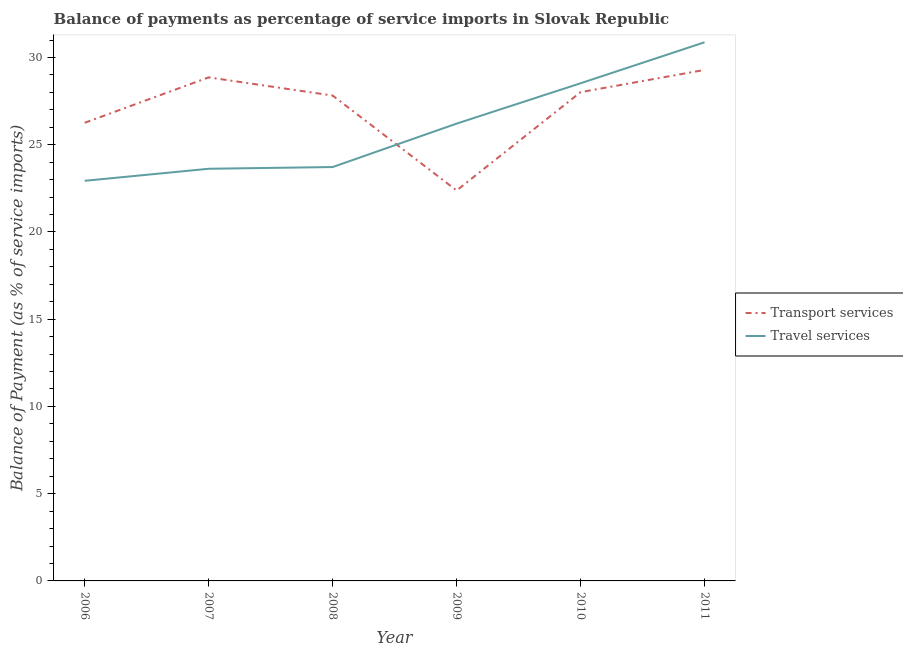Is the number of lines equal to the number of legend labels?
Give a very brief answer. Yes. What is the balance of payments of transport services in 2010?
Provide a succinct answer. 28.01. Across all years, what is the maximum balance of payments of transport services?
Keep it short and to the point. 29.29. Across all years, what is the minimum balance of payments of travel services?
Your answer should be compact. 22.93. In which year was the balance of payments of travel services maximum?
Your answer should be very brief. 2011. What is the total balance of payments of transport services in the graph?
Your answer should be very brief. 162.61. What is the difference between the balance of payments of transport services in 2006 and that in 2007?
Your answer should be compact. -2.6. What is the difference between the balance of payments of travel services in 2007 and the balance of payments of transport services in 2011?
Your answer should be very brief. -5.67. What is the average balance of payments of transport services per year?
Your response must be concise. 27.1. In the year 2007, what is the difference between the balance of payments of transport services and balance of payments of travel services?
Your response must be concise. 5.24. In how many years, is the balance of payments of transport services greater than 12 %?
Your response must be concise. 6. What is the ratio of the balance of payments of transport services in 2006 to that in 2010?
Provide a succinct answer. 0.94. What is the difference between the highest and the second highest balance of payments of travel services?
Your response must be concise. 2.35. What is the difference between the highest and the lowest balance of payments of transport services?
Offer a very short reply. 6.91. In how many years, is the balance of payments of travel services greater than the average balance of payments of travel services taken over all years?
Make the answer very short. 3. Does the balance of payments of travel services monotonically increase over the years?
Provide a short and direct response. Yes. Is the balance of payments of transport services strictly less than the balance of payments of travel services over the years?
Provide a short and direct response. No. How many years are there in the graph?
Your response must be concise. 6. What is the difference between two consecutive major ticks on the Y-axis?
Your answer should be compact. 5. Does the graph contain any zero values?
Provide a succinct answer. No. Does the graph contain grids?
Your response must be concise. No. What is the title of the graph?
Ensure brevity in your answer.  Balance of payments as percentage of service imports in Slovak Republic. What is the label or title of the X-axis?
Your answer should be compact. Year. What is the label or title of the Y-axis?
Provide a short and direct response. Balance of Payment (as % of service imports). What is the Balance of Payment (as % of service imports) of Transport services in 2006?
Your response must be concise. 26.26. What is the Balance of Payment (as % of service imports) in Travel services in 2006?
Your response must be concise. 22.93. What is the Balance of Payment (as % of service imports) in Transport services in 2007?
Offer a very short reply. 28.86. What is the Balance of Payment (as % of service imports) of Travel services in 2007?
Make the answer very short. 23.62. What is the Balance of Payment (as % of service imports) of Transport services in 2008?
Keep it short and to the point. 27.82. What is the Balance of Payment (as % of service imports) in Travel services in 2008?
Make the answer very short. 23.72. What is the Balance of Payment (as % of service imports) of Transport services in 2009?
Keep it short and to the point. 22.38. What is the Balance of Payment (as % of service imports) of Travel services in 2009?
Provide a short and direct response. 26.21. What is the Balance of Payment (as % of service imports) in Transport services in 2010?
Provide a short and direct response. 28.01. What is the Balance of Payment (as % of service imports) in Travel services in 2010?
Provide a short and direct response. 28.52. What is the Balance of Payment (as % of service imports) in Transport services in 2011?
Provide a short and direct response. 29.29. What is the Balance of Payment (as % of service imports) in Travel services in 2011?
Ensure brevity in your answer.  30.87. Across all years, what is the maximum Balance of Payment (as % of service imports) in Transport services?
Provide a succinct answer. 29.29. Across all years, what is the maximum Balance of Payment (as % of service imports) of Travel services?
Offer a terse response. 30.87. Across all years, what is the minimum Balance of Payment (as % of service imports) in Transport services?
Keep it short and to the point. 22.38. Across all years, what is the minimum Balance of Payment (as % of service imports) of Travel services?
Your answer should be compact. 22.93. What is the total Balance of Payment (as % of service imports) in Transport services in the graph?
Your response must be concise. 162.61. What is the total Balance of Payment (as % of service imports) of Travel services in the graph?
Provide a succinct answer. 155.88. What is the difference between the Balance of Payment (as % of service imports) in Transport services in 2006 and that in 2007?
Your response must be concise. -2.6. What is the difference between the Balance of Payment (as % of service imports) of Travel services in 2006 and that in 2007?
Give a very brief answer. -0.69. What is the difference between the Balance of Payment (as % of service imports) in Transport services in 2006 and that in 2008?
Ensure brevity in your answer.  -1.56. What is the difference between the Balance of Payment (as % of service imports) of Travel services in 2006 and that in 2008?
Your response must be concise. -0.79. What is the difference between the Balance of Payment (as % of service imports) in Transport services in 2006 and that in 2009?
Your answer should be very brief. 3.88. What is the difference between the Balance of Payment (as % of service imports) in Travel services in 2006 and that in 2009?
Provide a succinct answer. -3.28. What is the difference between the Balance of Payment (as % of service imports) of Transport services in 2006 and that in 2010?
Provide a short and direct response. -1.76. What is the difference between the Balance of Payment (as % of service imports) in Travel services in 2006 and that in 2010?
Offer a terse response. -5.59. What is the difference between the Balance of Payment (as % of service imports) in Transport services in 2006 and that in 2011?
Your answer should be compact. -3.03. What is the difference between the Balance of Payment (as % of service imports) of Travel services in 2006 and that in 2011?
Make the answer very short. -7.94. What is the difference between the Balance of Payment (as % of service imports) of Transport services in 2007 and that in 2008?
Make the answer very short. 1.04. What is the difference between the Balance of Payment (as % of service imports) in Travel services in 2007 and that in 2008?
Offer a terse response. -0.1. What is the difference between the Balance of Payment (as % of service imports) of Transport services in 2007 and that in 2009?
Your answer should be compact. 6.48. What is the difference between the Balance of Payment (as % of service imports) in Travel services in 2007 and that in 2009?
Ensure brevity in your answer.  -2.59. What is the difference between the Balance of Payment (as % of service imports) of Transport services in 2007 and that in 2010?
Give a very brief answer. 0.85. What is the difference between the Balance of Payment (as % of service imports) in Travel services in 2007 and that in 2010?
Ensure brevity in your answer.  -4.9. What is the difference between the Balance of Payment (as % of service imports) in Transport services in 2007 and that in 2011?
Offer a terse response. -0.43. What is the difference between the Balance of Payment (as % of service imports) of Travel services in 2007 and that in 2011?
Make the answer very short. -7.25. What is the difference between the Balance of Payment (as % of service imports) in Transport services in 2008 and that in 2009?
Your answer should be compact. 5.44. What is the difference between the Balance of Payment (as % of service imports) in Travel services in 2008 and that in 2009?
Provide a succinct answer. -2.49. What is the difference between the Balance of Payment (as % of service imports) in Transport services in 2008 and that in 2010?
Offer a very short reply. -0.2. What is the difference between the Balance of Payment (as % of service imports) of Travel services in 2008 and that in 2010?
Offer a terse response. -4.8. What is the difference between the Balance of Payment (as % of service imports) in Transport services in 2008 and that in 2011?
Provide a succinct answer. -1.47. What is the difference between the Balance of Payment (as % of service imports) in Travel services in 2008 and that in 2011?
Give a very brief answer. -7.15. What is the difference between the Balance of Payment (as % of service imports) in Transport services in 2009 and that in 2010?
Provide a succinct answer. -5.64. What is the difference between the Balance of Payment (as % of service imports) in Travel services in 2009 and that in 2010?
Make the answer very short. -2.31. What is the difference between the Balance of Payment (as % of service imports) in Transport services in 2009 and that in 2011?
Your answer should be very brief. -6.91. What is the difference between the Balance of Payment (as % of service imports) in Travel services in 2009 and that in 2011?
Give a very brief answer. -4.66. What is the difference between the Balance of Payment (as % of service imports) of Transport services in 2010 and that in 2011?
Ensure brevity in your answer.  -1.27. What is the difference between the Balance of Payment (as % of service imports) of Travel services in 2010 and that in 2011?
Provide a short and direct response. -2.35. What is the difference between the Balance of Payment (as % of service imports) of Transport services in 2006 and the Balance of Payment (as % of service imports) of Travel services in 2007?
Provide a succinct answer. 2.64. What is the difference between the Balance of Payment (as % of service imports) of Transport services in 2006 and the Balance of Payment (as % of service imports) of Travel services in 2008?
Ensure brevity in your answer.  2.54. What is the difference between the Balance of Payment (as % of service imports) in Transport services in 2006 and the Balance of Payment (as % of service imports) in Travel services in 2009?
Give a very brief answer. 0.05. What is the difference between the Balance of Payment (as % of service imports) in Transport services in 2006 and the Balance of Payment (as % of service imports) in Travel services in 2010?
Ensure brevity in your answer.  -2.26. What is the difference between the Balance of Payment (as % of service imports) of Transport services in 2006 and the Balance of Payment (as % of service imports) of Travel services in 2011?
Keep it short and to the point. -4.61. What is the difference between the Balance of Payment (as % of service imports) in Transport services in 2007 and the Balance of Payment (as % of service imports) in Travel services in 2008?
Provide a succinct answer. 5.14. What is the difference between the Balance of Payment (as % of service imports) of Transport services in 2007 and the Balance of Payment (as % of service imports) of Travel services in 2009?
Give a very brief answer. 2.65. What is the difference between the Balance of Payment (as % of service imports) of Transport services in 2007 and the Balance of Payment (as % of service imports) of Travel services in 2010?
Give a very brief answer. 0.34. What is the difference between the Balance of Payment (as % of service imports) in Transport services in 2007 and the Balance of Payment (as % of service imports) in Travel services in 2011?
Offer a very short reply. -2.01. What is the difference between the Balance of Payment (as % of service imports) of Transport services in 2008 and the Balance of Payment (as % of service imports) of Travel services in 2009?
Ensure brevity in your answer.  1.61. What is the difference between the Balance of Payment (as % of service imports) of Transport services in 2008 and the Balance of Payment (as % of service imports) of Travel services in 2010?
Make the answer very short. -0.7. What is the difference between the Balance of Payment (as % of service imports) of Transport services in 2008 and the Balance of Payment (as % of service imports) of Travel services in 2011?
Provide a succinct answer. -3.05. What is the difference between the Balance of Payment (as % of service imports) in Transport services in 2009 and the Balance of Payment (as % of service imports) in Travel services in 2010?
Offer a very short reply. -6.14. What is the difference between the Balance of Payment (as % of service imports) in Transport services in 2009 and the Balance of Payment (as % of service imports) in Travel services in 2011?
Your response must be concise. -8.49. What is the difference between the Balance of Payment (as % of service imports) of Transport services in 2010 and the Balance of Payment (as % of service imports) of Travel services in 2011?
Your answer should be very brief. -2.86. What is the average Balance of Payment (as % of service imports) of Transport services per year?
Offer a terse response. 27.1. What is the average Balance of Payment (as % of service imports) in Travel services per year?
Your response must be concise. 25.98. In the year 2006, what is the difference between the Balance of Payment (as % of service imports) in Transport services and Balance of Payment (as % of service imports) in Travel services?
Provide a short and direct response. 3.33. In the year 2007, what is the difference between the Balance of Payment (as % of service imports) of Transport services and Balance of Payment (as % of service imports) of Travel services?
Provide a short and direct response. 5.24. In the year 2008, what is the difference between the Balance of Payment (as % of service imports) in Transport services and Balance of Payment (as % of service imports) in Travel services?
Make the answer very short. 4.1. In the year 2009, what is the difference between the Balance of Payment (as % of service imports) of Transport services and Balance of Payment (as % of service imports) of Travel services?
Provide a succinct answer. -3.83. In the year 2010, what is the difference between the Balance of Payment (as % of service imports) in Transport services and Balance of Payment (as % of service imports) in Travel services?
Offer a terse response. -0.51. In the year 2011, what is the difference between the Balance of Payment (as % of service imports) of Transport services and Balance of Payment (as % of service imports) of Travel services?
Offer a very short reply. -1.58. What is the ratio of the Balance of Payment (as % of service imports) in Transport services in 2006 to that in 2007?
Give a very brief answer. 0.91. What is the ratio of the Balance of Payment (as % of service imports) in Travel services in 2006 to that in 2007?
Your answer should be compact. 0.97. What is the ratio of the Balance of Payment (as % of service imports) of Transport services in 2006 to that in 2008?
Ensure brevity in your answer.  0.94. What is the ratio of the Balance of Payment (as % of service imports) of Travel services in 2006 to that in 2008?
Keep it short and to the point. 0.97. What is the ratio of the Balance of Payment (as % of service imports) in Transport services in 2006 to that in 2009?
Your answer should be very brief. 1.17. What is the ratio of the Balance of Payment (as % of service imports) of Transport services in 2006 to that in 2010?
Offer a terse response. 0.94. What is the ratio of the Balance of Payment (as % of service imports) in Travel services in 2006 to that in 2010?
Provide a succinct answer. 0.8. What is the ratio of the Balance of Payment (as % of service imports) in Transport services in 2006 to that in 2011?
Ensure brevity in your answer.  0.9. What is the ratio of the Balance of Payment (as % of service imports) in Travel services in 2006 to that in 2011?
Your response must be concise. 0.74. What is the ratio of the Balance of Payment (as % of service imports) in Transport services in 2007 to that in 2008?
Your answer should be compact. 1.04. What is the ratio of the Balance of Payment (as % of service imports) in Travel services in 2007 to that in 2008?
Keep it short and to the point. 1. What is the ratio of the Balance of Payment (as % of service imports) in Transport services in 2007 to that in 2009?
Ensure brevity in your answer.  1.29. What is the ratio of the Balance of Payment (as % of service imports) of Travel services in 2007 to that in 2009?
Your answer should be very brief. 0.9. What is the ratio of the Balance of Payment (as % of service imports) of Transport services in 2007 to that in 2010?
Ensure brevity in your answer.  1.03. What is the ratio of the Balance of Payment (as % of service imports) of Travel services in 2007 to that in 2010?
Ensure brevity in your answer.  0.83. What is the ratio of the Balance of Payment (as % of service imports) of Transport services in 2007 to that in 2011?
Ensure brevity in your answer.  0.99. What is the ratio of the Balance of Payment (as % of service imports) of Travel services in 2007 to that in 2011?
Provide a short and direct response. 0.77. What is the ratio of the Balance of Payment (as % of service imports) of Transport services in 2008 to that in 2009?
Make the answer very short. 1.24. What is the ratio of the Balance of Payment (as % of service imports) in Travel services in 2008 to that in 2009?
Make the answer very short. 0.91. What is the ratio of the Balance of Payment (as % of service imports) in Transport services in 2008 to that in 2010?
Your answer should be compact. 0.99. What is the ratio of the Balance of Payment (as % of service imports) in Travel services in 2008 to that in 2010?
Keep it short and to the point. 0.83. What is the ratio of the Balance of Payment (as % of service imports) of Transport services in 2008 to that in 2011?
Provide a short and direct response. 0.95. What is the ratio of the Balance of Payment (as % of service imports) in Travel services in 2008 to that in 2011?
Ensure brevity in your answer.  0.77. What is the ratio of the Balance of Payment (as % of service imports) of Transport services in 2009 to that in 2010?
Provide a short and direct response. 0.8. What is the ratio of the Balance of Payment (as % of service imports) in Travel services in 2009 to that in 2010?
Offer a very short reply. 0.92. What is the ratio of the Balance of Payment (as % of service imports) in Transport services in 2009 to that in 2011?
Your response must be concise. 0.76. What is the ratio of the Balance of Payment (as % of service imports) in Travel services in 2009 to that in 2011?
Your answer should be very brief. 0.85. What is the ratio of the Balance of Payment (as % of service imports) of Transport services in 2010 to that in 2011?
Keep it short and to the point. 0.96. What is the ratio of the Balance of Payment (as % of service imports) in Travel services in 2010 to that in 2011?
Ensure brevity in your answer.  0.92. What is the difference between the highest and the second highest Balance of Payment (as % of service imports) in Transport services?
Make the answer very short. 0.43. What is the difference between the highest and the second highest Balance of Payment (as % of service imports) of Travel services?
Make the answer very short. 2.35. What is the difference between the highest and the lowest Balance of Payment (as % of service imports) of Transport services?
Give a very brief answer. 6.91. What is the difference between the highest and the lowest Balance of Payment (as % of service imports) of Travel services?
Keep it short and to the point. 7.94. 